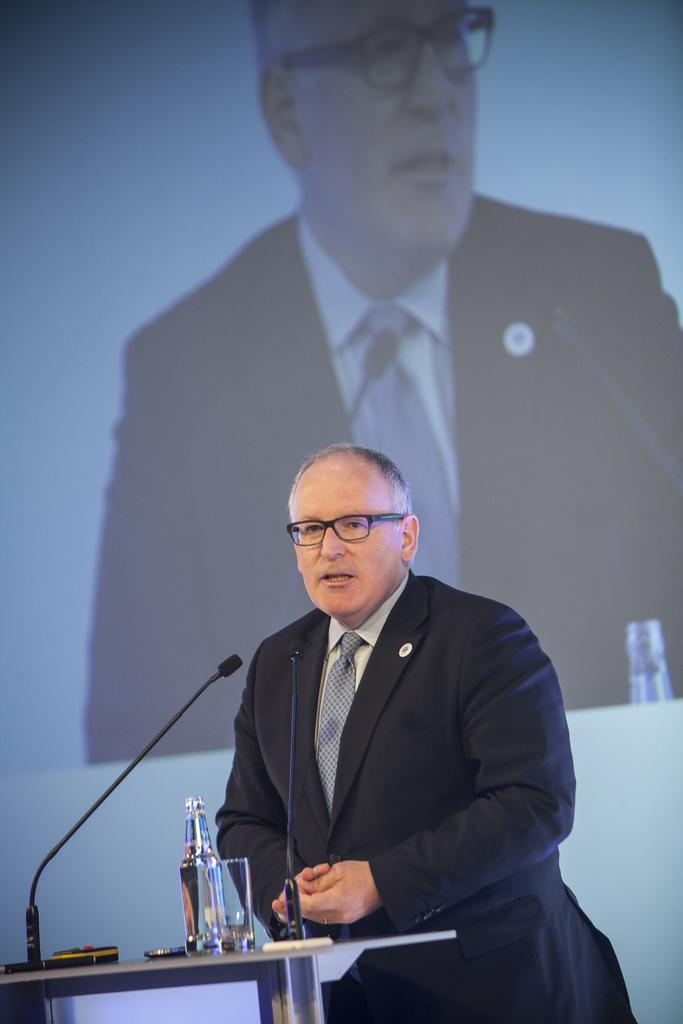What is the person in the image doing? The person is standing in front of the table. What objects are on the table? The table contains a bottle, a glass, and microphones (mics). What is the purpose of the microphones on the table? The microphones are likely used for recording or amplifying sound. What can be seen in the background of the image? There is a projection of a person in the background. What type of plastic oil is being used by the person in the image? There is no plastic oil present in the image, and the person is not using any oil. 